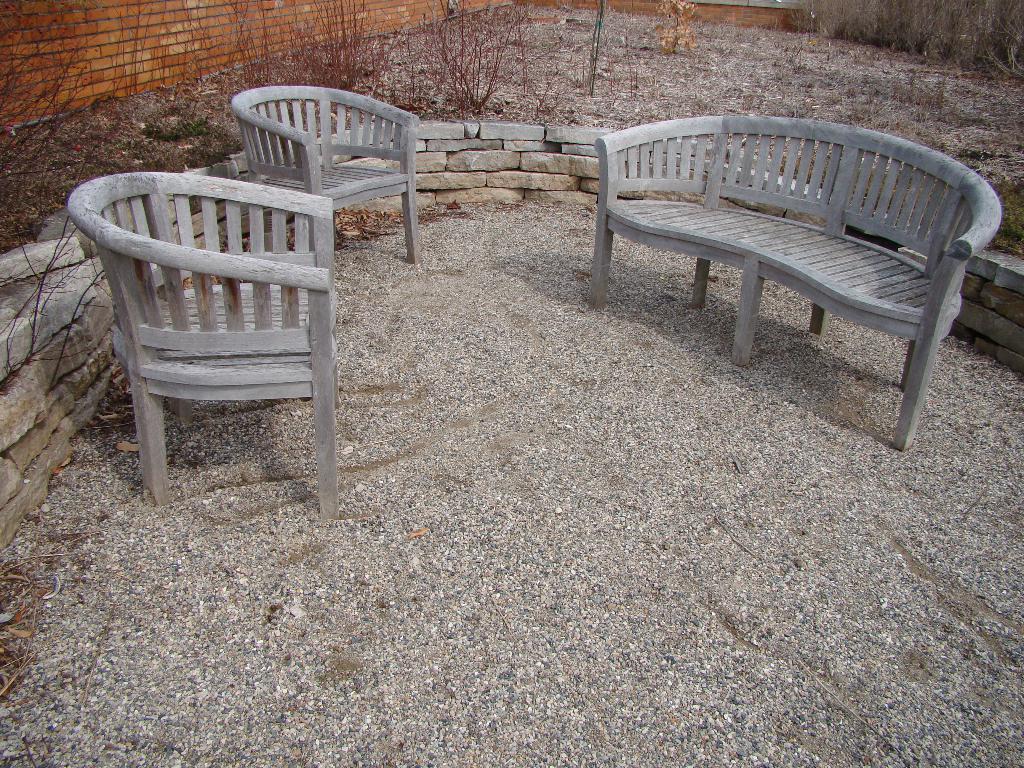Describe this image in one or two sentences. In the picture I can see few chairs on small rocks and there is a fence around it which is made of rocks and there are few plants and a fence wall in the background. 